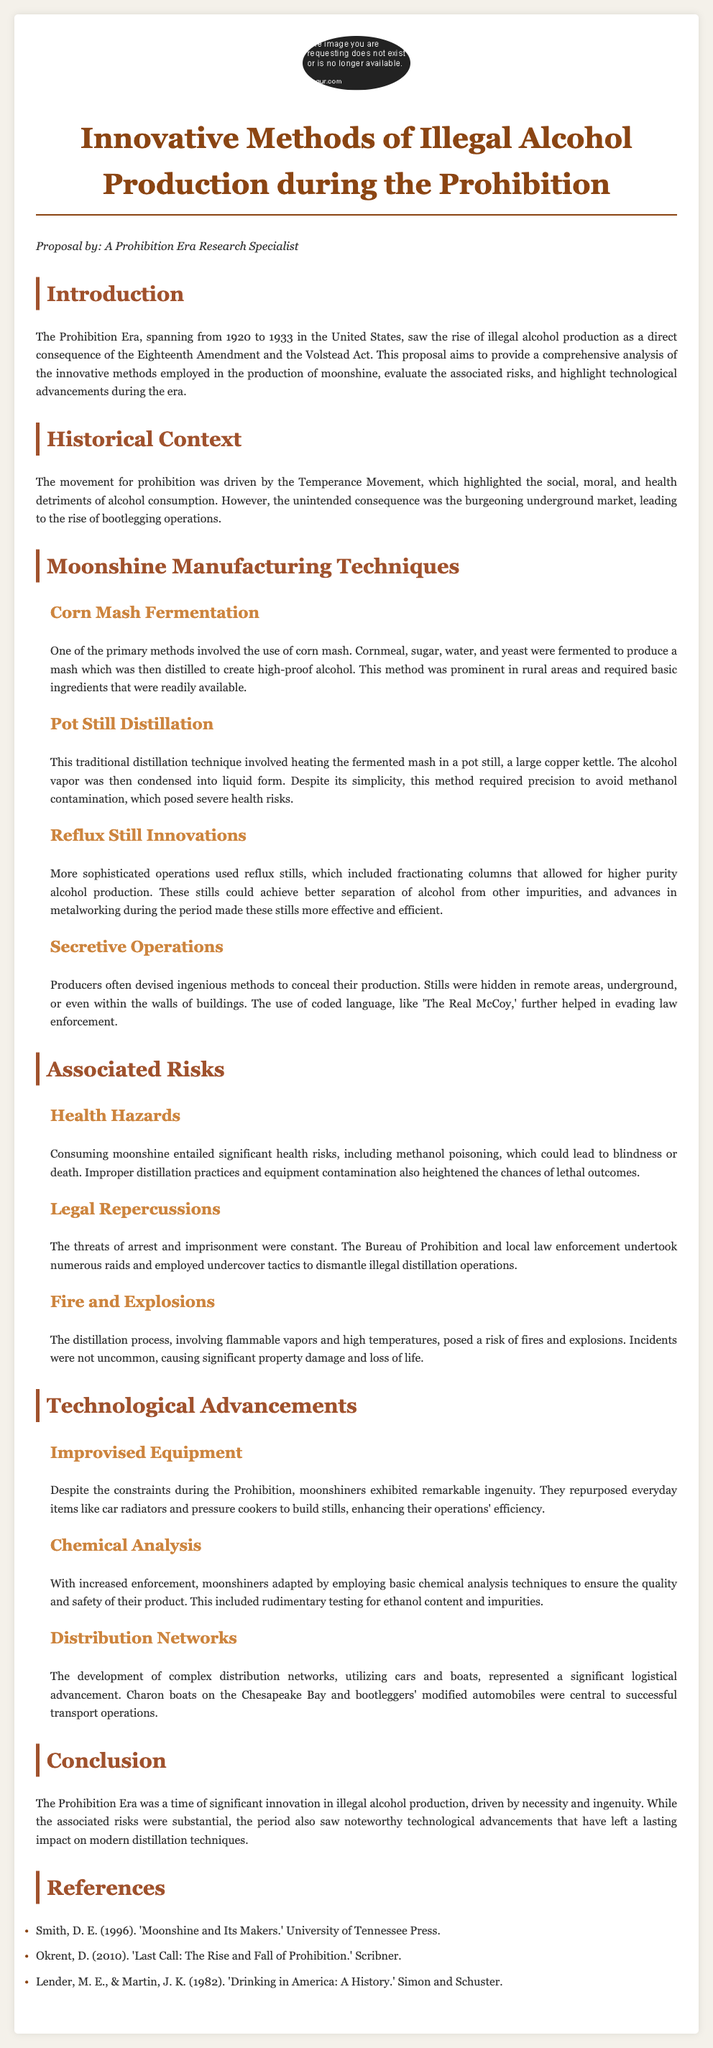what years did the Prohibition Era span? The Prohibition Era is identified in the document as occurring from 1920 to 1933.
Answer: 1920 to 1933 what primary method was used in corn mash fermentation? The document states that the primary method involved using cornmeal, sugar, water, and yeast fermented together.
Answer: Cornmeal, sugar, water, and yeast what legal threat did moonshiners face? The document describes the constant threats of arrest and imprisonment due to the activities of the Bureau of Prohibition.
Answer: Arrest and imprisonment what risk is associated with improper distillation practices? The document mentions that improper distillation can lead to methanol poisoning, which could cause blindness or death.
Answer: Methanol poisoning what is one improvised item used in moonshine production? According to the document, moonshiners repurposed everyday items like car radiators to build stills.
Answer: Car radiators what did moonshiners employ for quality assurance? The document indicates that basic chemical analysis techniques were used to ensure product quality and safety.
Answer: Chemical analysis techniques which specific advancement helped in higher purity alcohol production? The document highlights that reflux stills, which included fractionating columns, allowed for better separation of alcohol from impurities.
Answer: Reflux stills who were the operators behind illegal alcohol distribution networks? The document refers to "bootleggers" as being central to the distribution networks developed.
Answer: Bootleggers 